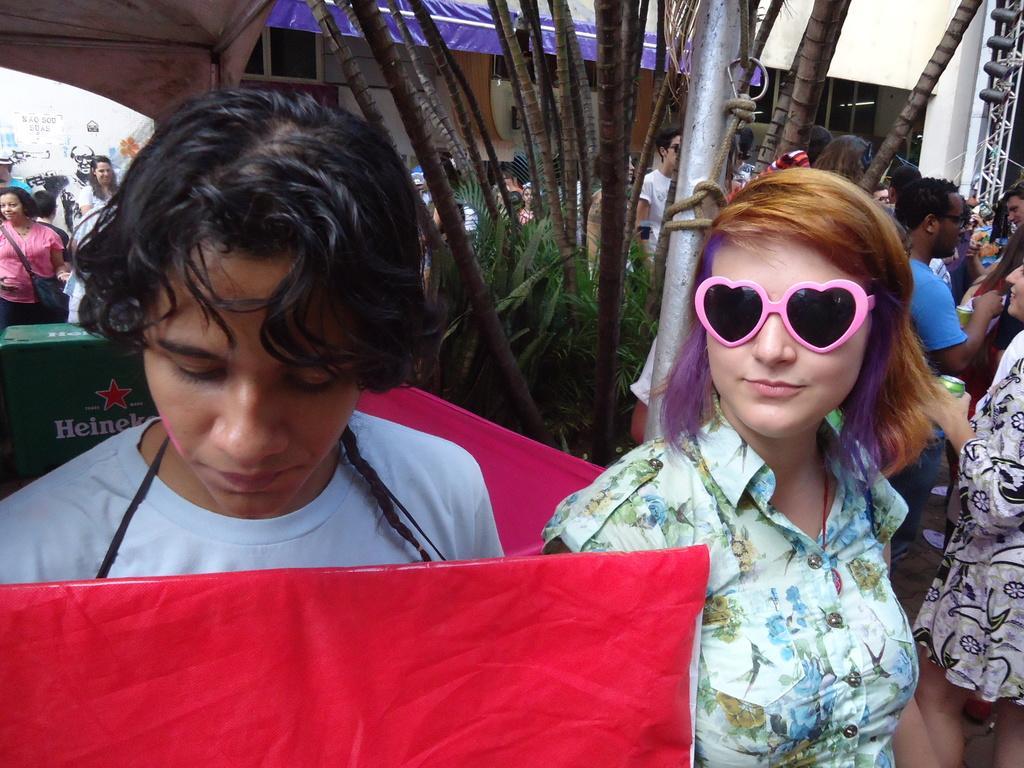Please provide a concise description of this image. In this image, we can see a group of people. Few are holding some objects. Here a woman is wearing goggles and smiling. Background we can see plants, pole, banner, pillars, some objects and wall. 